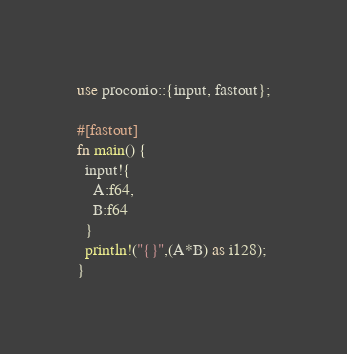Convert code to text. <code><loc_0><loc_0><loc_500><loc_500><_Rust_>use proconio::{input, fastout};

#[fastout]
fn main() {
  input!{
    A:f64,
    B:f64
  }
  println!("{}",(A*B) as i128);
}
</code> 